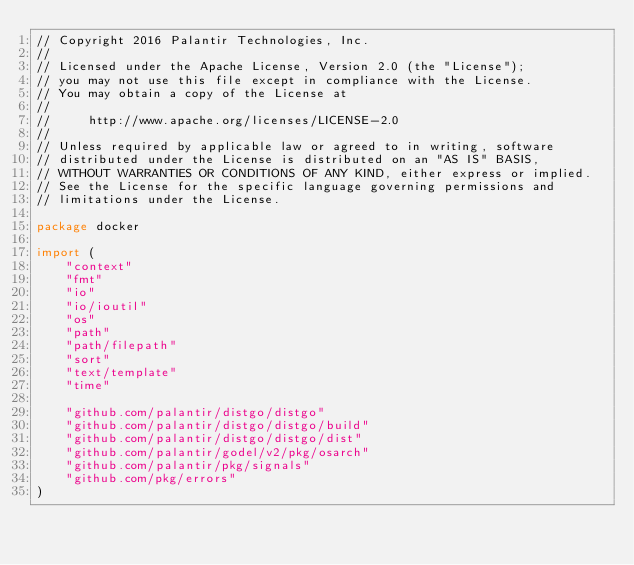<code> <loc_0><loc_0><loc_500><loc_500><_Go_>// Copyright 2016 Palantir Technologies, Inc.
//
// Licensed under the Apache License, Version 2.0 (the "License");
// you may not use this file except in compliance with the License.
// You may obtain a copy of the License at
//
//     http://www.apache.org/licenses/LICENSE-2.0
//
// Unless required by applicable law or agreed to in writing, software
// distributed under the License is distributed on an "AS IS" BASIS,
// WITHOUT WARRANTIES OR CONDITIONS OF ANY KIND, either express or implied.
// See the License for the specific language governing permissions and
// limitations under the License.

package docker

import (
	"context"
	"fmt"
	"io"
	"io/ioutil"
	"os"
	"path"
	"path/filepath"
	"sort"
	"text/template"
	"time"

	"github.com/palantir/distgo/distgo"
	"github.com/palantir/distgo/distgo/build"
	"github.com/palantir/distgo/distgo/dist"
	"github.com/palantir/godel/v2/pkg/osarch"
	"github.com/palantir/pkg/signals"
	"github.com/pkg/errors"
)
</code> 